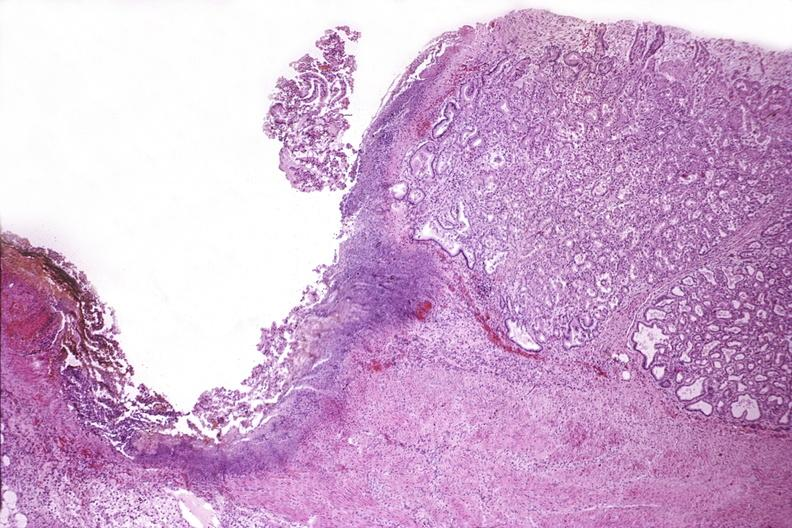s gastrointestinal present?
Answer the question using a single word or phrase. Yes 